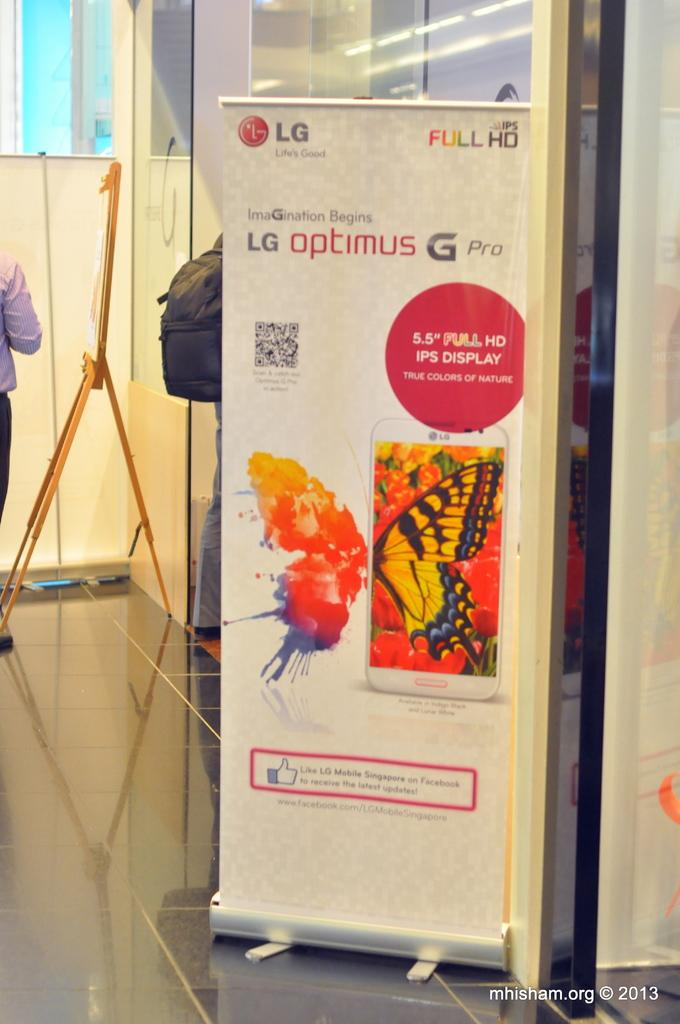<image>
Present a compact description of the photo's key features. A display showcasing the LG Optimus G Pro phone with the photo of a butterfly. 